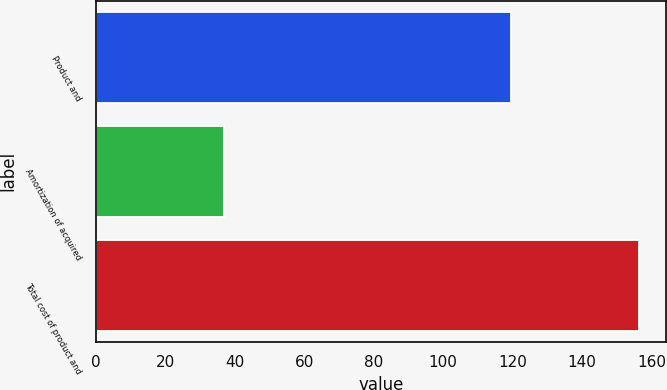<chart> <loc_0><loc_0><loc_500><loc_500><bar_chart><fcel>Product and<fcel>Amortization of acquired<fcel>Total cost of product and<nl><fcel>119.4<fcel>36.9<fcel>156.3<nl></chart> 